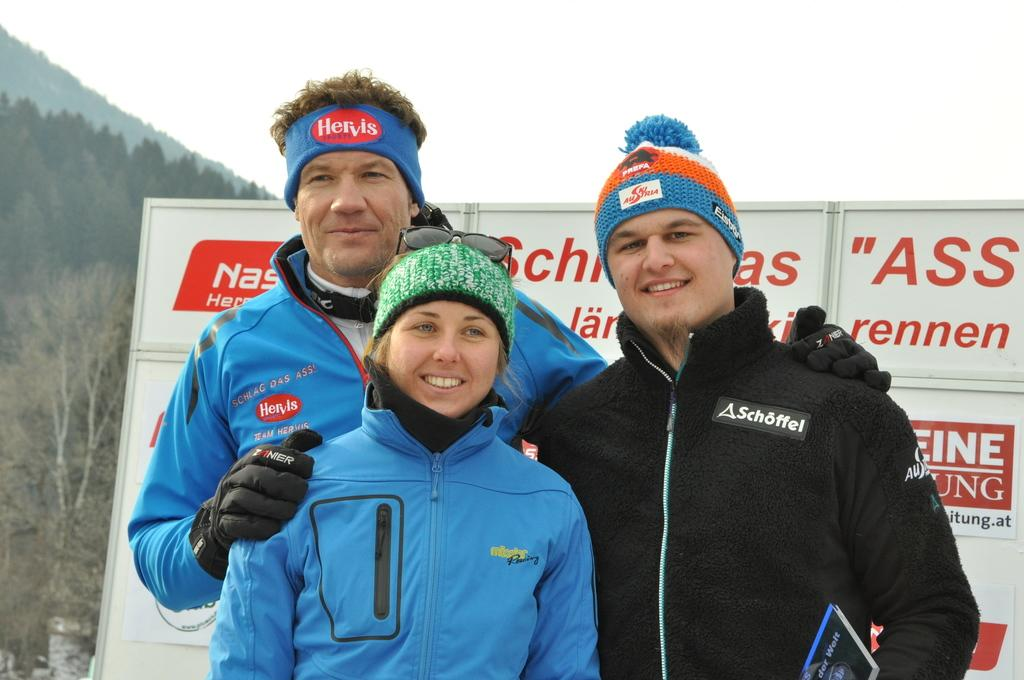How many people are in the image? There are two men and a woman in the image. What are the individuals wearing on their heads? The individuals are wearing caps. What type of clothing are the individuals wearing on their upper bodies? The individuals are wearing jackets. What are the individuals doing in the image? The individuals are standing and smiling. What can be seen in the background of the image? There are boards and trees in the background of the image, as well as the sky. What is the theory behind the feeling of smashing the boards in the image? There is no mention of smashing boards or any related theory in the image. The individuals are simply standing and smiling, and there are boards visible in the background. 